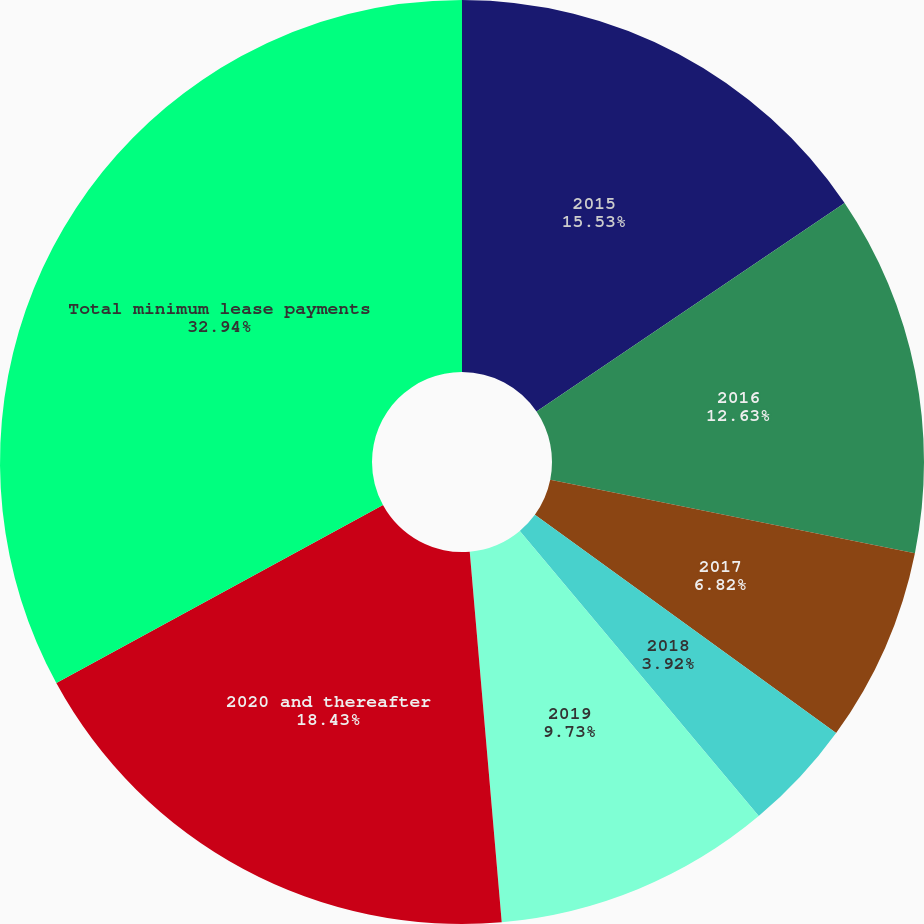Convert chart to OTSL. <chart><loc_0><loc_0><loc_500><loc_500><pie_chart><fcel>2015<fcel>2016<fcel>2017<fcel>2018<fcel>2019<fcel>2020 and thereafter<fcel>Total minimum lease payments<nl><fcel>15.53%<fcel>12.63%<fcel>6.82%<fcel>3.92%<fcel>9.73%<fcel>18.43%<fcel>32.94%<nl></chart> 